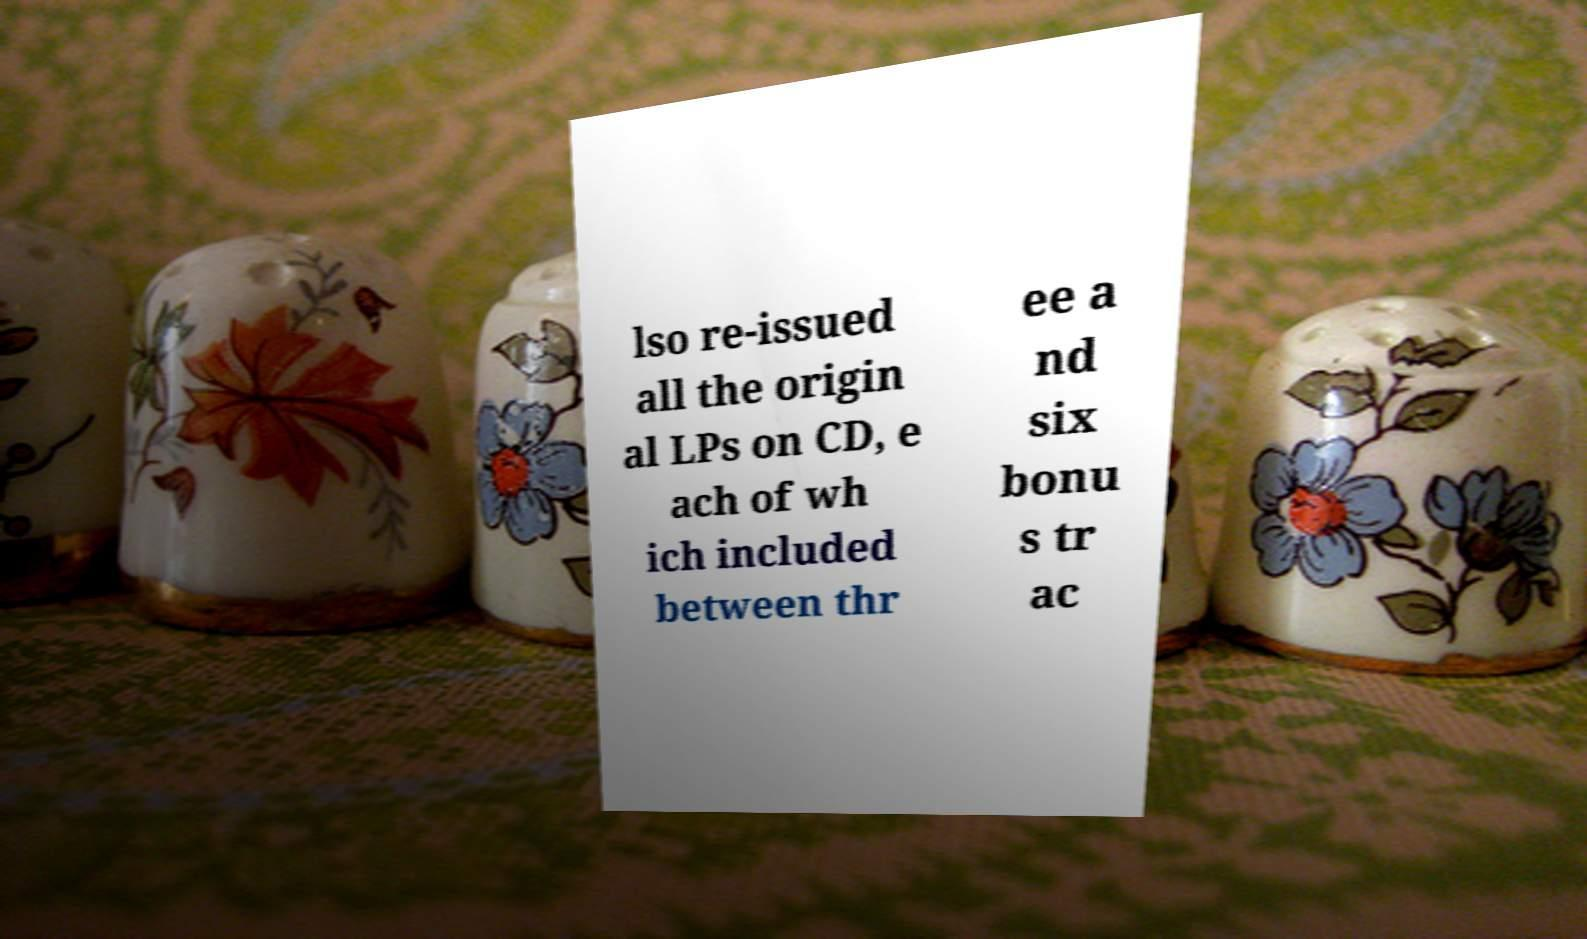What messages or text are displayed in this image? I need them in a readable, typed format. lso re-issued all the origin al LPs on CD, e ach of wh ich included between thr ee a nd six bonu s tr ac 